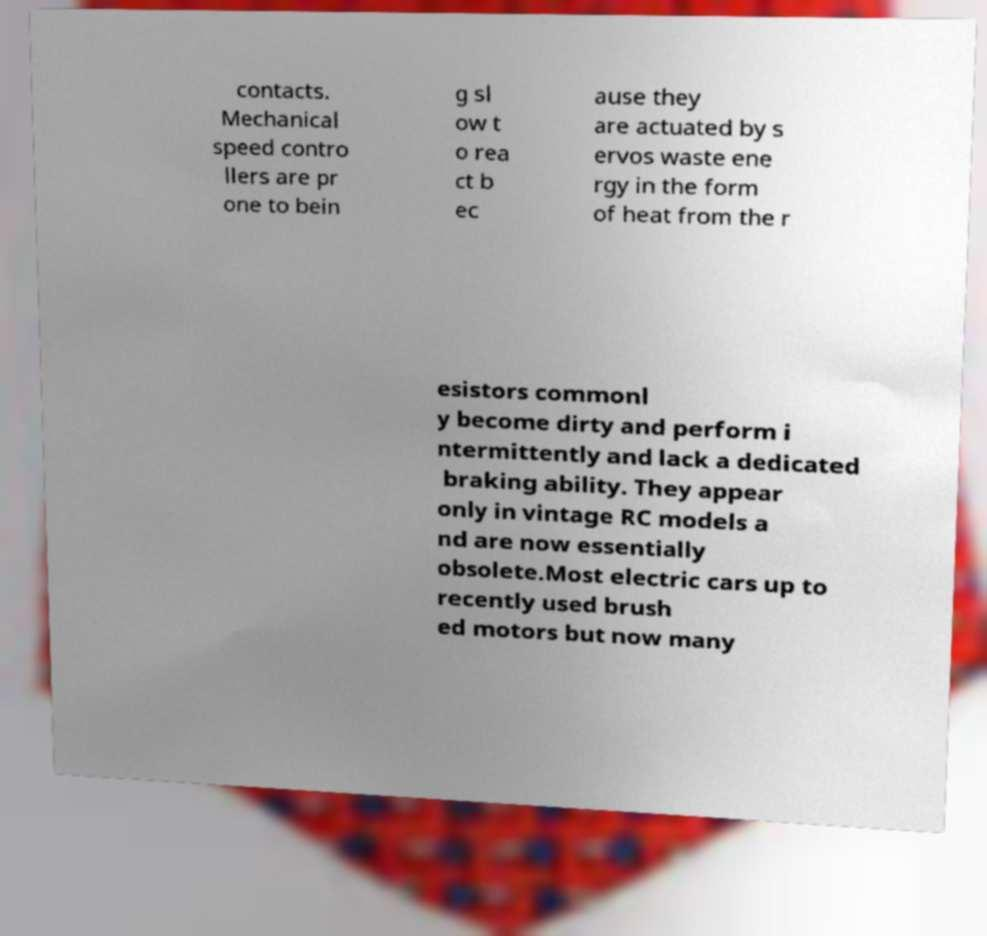I need the written content from this picture converted into text. Can you do that? contacts. Mechanical speed contro llers are pr one to bein g sl ow t o rea ct b ec ause they are actuated by s ervos waste ene rgy in the form of heat from the r esistors commonl y become dirty and perform i ntermittently and lack a dedicated braking ability. They appear only in vintage RC models a nd are now essentially obsolete.Most electric cars up to recently used brush ed motors but now many 